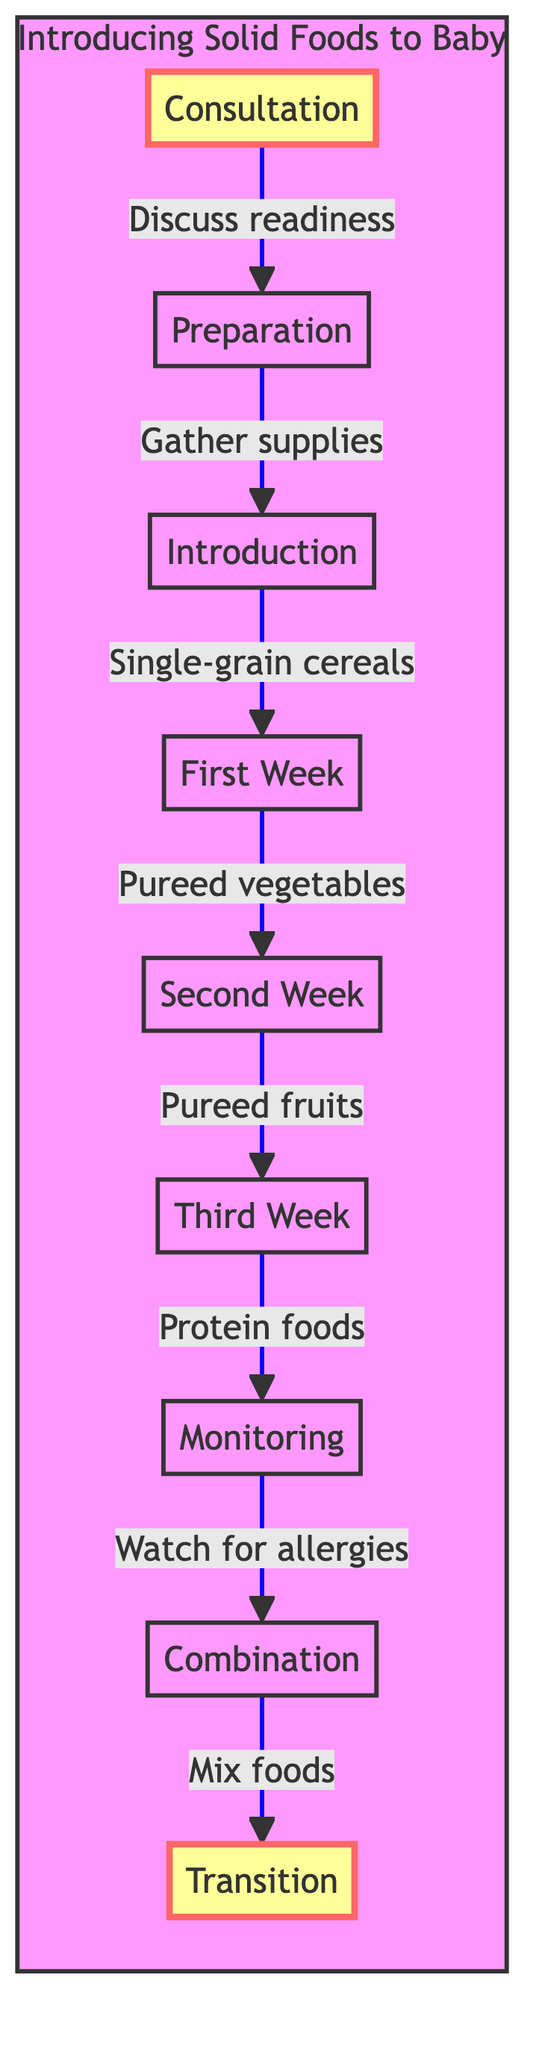What is the first stage in the process? The first stage in the diagram is labeled "Consultation." It is the starting point of the flowchart, indicating the first step a new mom should take in the process of introducing solid foods.
Answer: Consultation How many stages are there in total? By counting the stages listed in the flowchart, there are a total of eight distinct stages from "Consultation" to "Transition."
Answer: Eight Which stage comes after "Monitoring"? Following the "Monitoring" stage, the next stage indicated in the flowchart is "Combination." This means after observing for any allergic reactions, the next step is to mix previously introduced foods.
Answer: Combination What type of food should be introduced in the first week? The diagram specifies that during the "First Week," the solid food introduced should be "Pureed Vegetables." This indicates that it's the focus of that particular stage.
Answer: Pureed Vegetables What is the purpose of the "Observation" stage? The "Monitoring" stage, or "Observation," is crucial as it requires watching for signs of allergies like rashes, vomiting, or diarrhea, ensuring the baby can safely tolerate the newly introduced foods.
Answer: Allergic reactions How does "Transition" relate to previous stages? The "Transition" stage logically follows the "Combination" stage, as it involves moving to chunkier textures. It requires the integration of previously introduced foods and evaluates the baby’s capability of handling more solid food.
Answer: Chunkier Textures What food is recommended for the "Introduction" stage? In the "Introduction" stage, the recommended food type is "Single-Grain Cereals," which should be iron-fortified rice or oatmeal cereal mixed with either breast milk or formula.
Answer: Single-Grain Cereals Which stage requires consulting a pediatrician? The "Consultation" stage is where consultation with a pediatrician occurs, ensuring the baby is ready for solid foods and checking for any potential allergies.
Answer: Consultation 